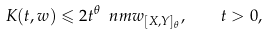Convert formula to latex. <formula><loc_0><loc_0><loc_500><loc_500>K ( t , w ) \leqslant 2 t ^ { \theta } \ n m { w } _ { [ X , Y ] _ { \theta } } , \quad t > 0 ,</formula> 